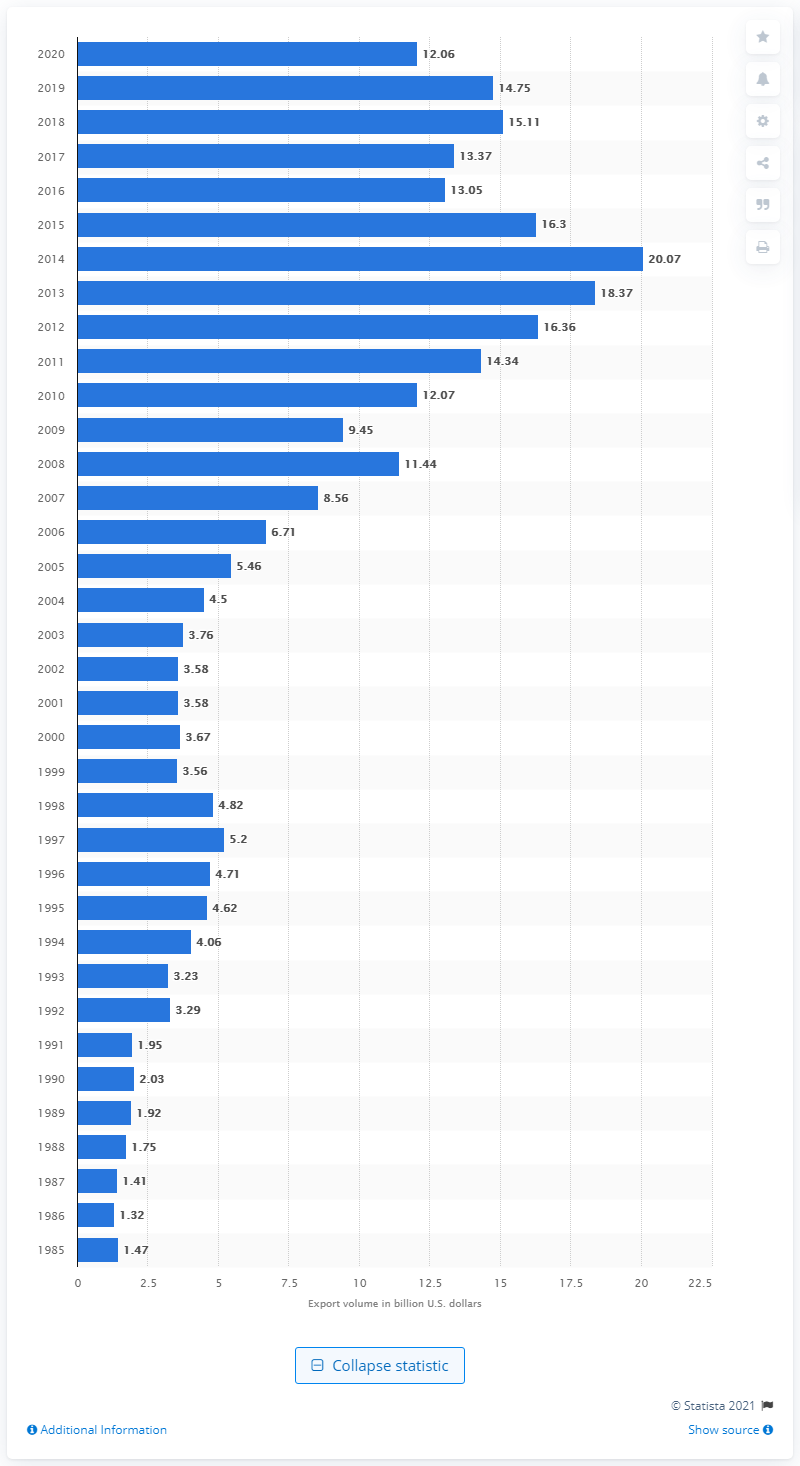Could there be any significant global events that influenced the fluctuations in exports depicted in the chart? Yes, global events can significantly influence trade flows. For instance, the peak in 2013 may be related to the U.S.-Colombia Trade Promotion Agreement, which came into effect in 2012. Following years might have experienced fluctuations due to various factors including economic policies, commodity prices, or geopolitical situations. The dip in 2020 could potentially be attributed to the global impact of the COVID-19 pandemic. 